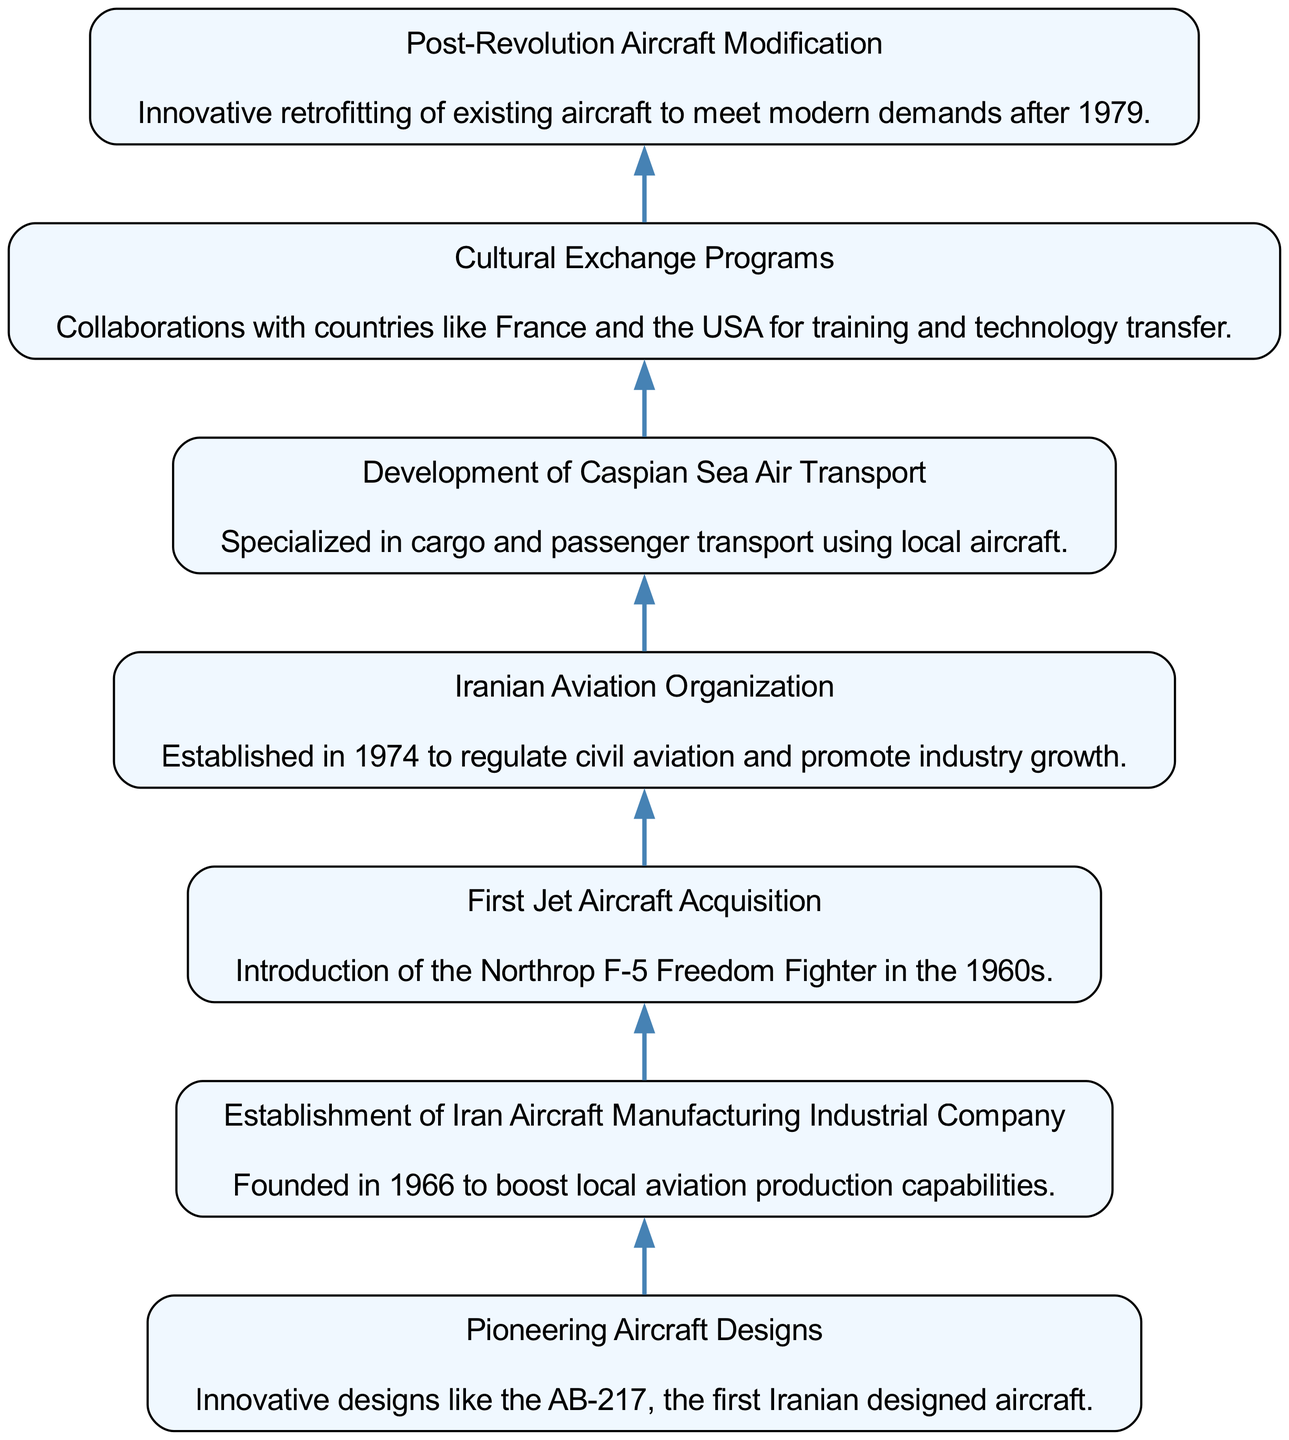What is the first node in the diagram? The first node in the diagram depicts "Pioneering Aircraft Designs." By reviewing the sequence in the flow chart, the starting point is listed first and corresponds to this specific element.
Answer: Pioneering Aircraft Designs How many nodes are present in the diagram? There are a total of 7 nodes in the diagram, representing each significant innovation and contribution. Counting each labeled box gives us this number.
Answer: 7 Which node describes the establishment of a regulatory body? The "Iranian Aviation Organization" node details the establishment of a regulatory body aimed at promoting industry growth. This information is found in the description of that particular node.
Answer: Iranian Aviation Organization What innovation occurred after the establishment of the Iran Aircraft Manufacturing Industrial Company? The "First Jet Aircraft Acquisition," with the introduction of the Northrop F-5 Freedom Fighter, occurred after the establishment of the Iran Aircraft Manufacturing Industrial Company. This can be determined by examining the sequential flow of the nodes.
Answer: First Jet Aircraft Acquisition Which two nodes indicate international collaboration? The "Cultural Exchange Programs" node reflects the collaboration with countries like France and the USA, while "First Jet Aircraft Acquisition" signifies the introduction of an American aircraft. Both nodes indicate international collaboration in Iran's aviation history.
Answer: Cultural Exchange Programs and First Jet Aircraft Acquisition Identify the node that involves aircraft retrofitting. The "Post-Revolution Aircraft Modification" node discusses the innovative retrofitting of existing aircraft to meet modern demands following the 1979 revolution. Looking for keywords in the description leads us here.
Answer: Post-Revolution Aircraft Modification What is the common theme among the nodes? The common theme among all nodes is advancements in aviation, focusing on designing, manufacturing, regulatory aspects, and international relations. This conclusion can be drawn by analyzing the overarching goal of each node.
Answer: Advancements in aviation What was the primary goal of the establishment of the Iranian Aviation Organization? The primary goal was to regulate civil aviation and promote industry growth, as stated in the node's description. This shows the direct purpose of the organization's creation.
Answer: Regulate civil aviation and promote industry growth 